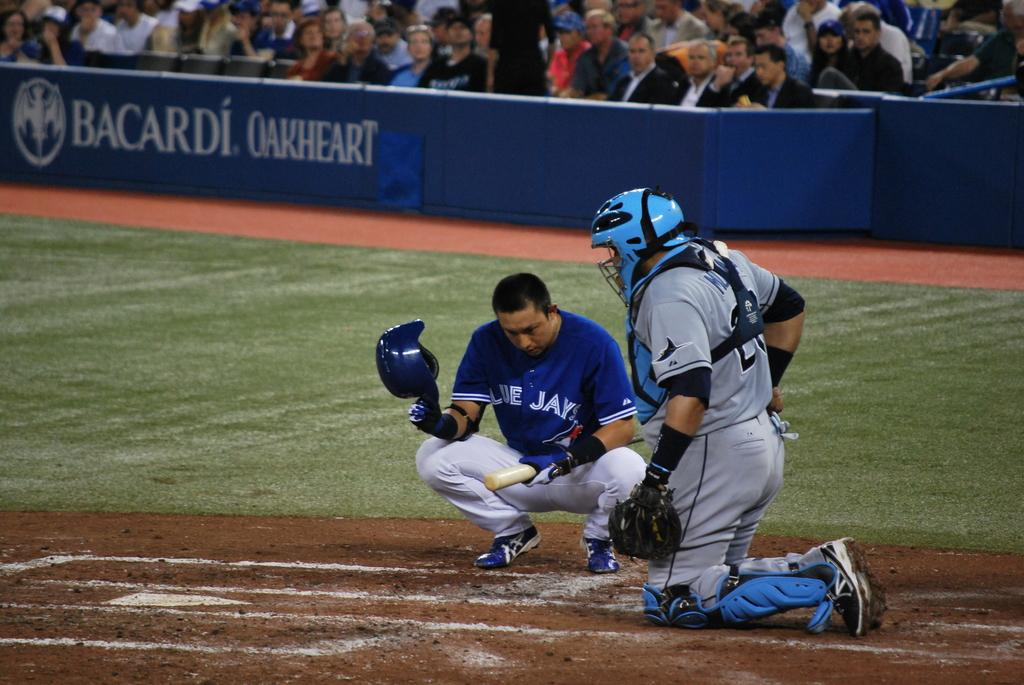<image>
Write a terse but informative summary of the picture. A Blue Jays baseball player squats in front of the catcher before batting. 